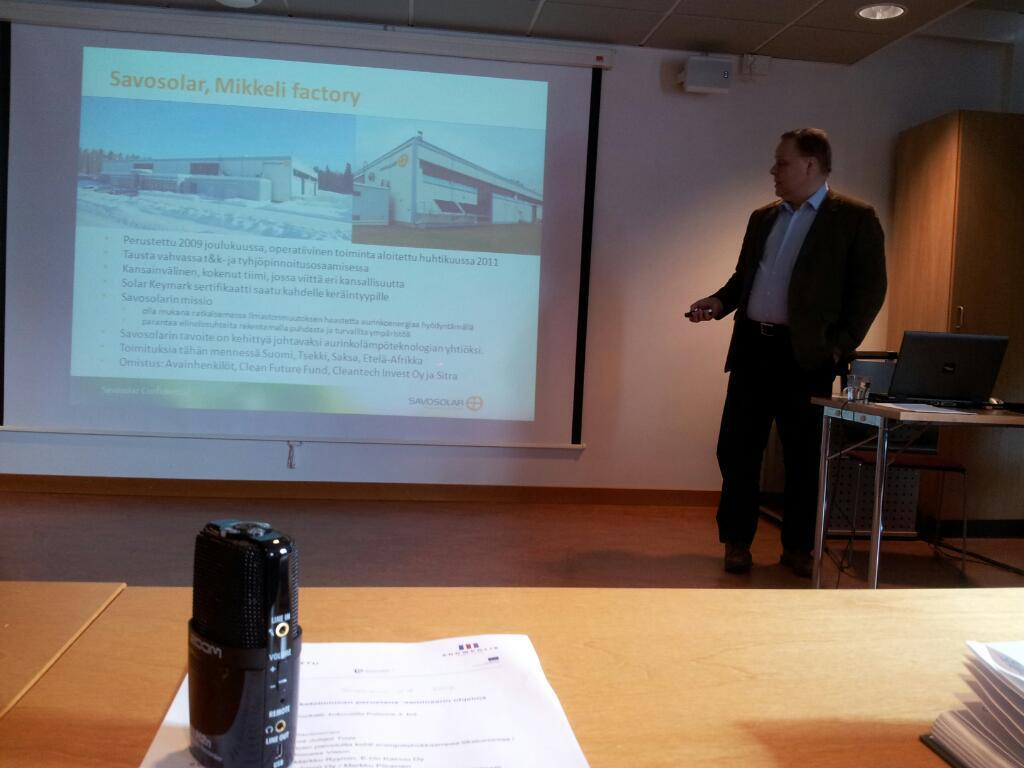What is the main subject of the image? There is a person standing in the image. Where is the person standing in relation to other objects? The person is standing in front of a table. What can be seen on the table? There are many items on the table. What is on the wall in the image? There is a screen on the wall in the image. What type of nut is being cracked on the table in the image? There is no nut present in the image, nor is there any activity of cracking a nut. 